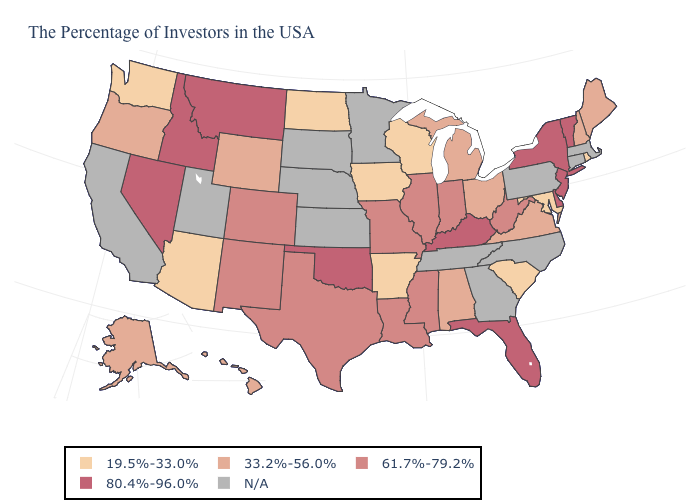Does the map have missing data?
Keep it brief. Yes. What is the value of Florida?
Short answer required. 80.4%-96.0%. What is the value of Florida?
Short answer required. 80.4%-96.0%. Does the map have missing data?
Give a very brief answer. Yes. Does Hawaii have the lowest value in the USA?
Quick response, please. No. How many symbols are there in the legend?
Short answer required. 5. What is the lowest value in states that border North Dakota?
Short answer required. 80.4%-96.0%. What is the highest value in states that border Idaho?
Keep it brief. 80.4%-96.0%. Does the map have missing data?
Answer briefly. Yes. What is the highest value in the West ?
Keep it brief. 80.4%-96.0%. Is the legend a continuous bar?
Answer briefly. No. How many symbols are there in the legend?
Keep it brief. 5. What is the lowest value in the Northeast?
Give a very brief answer. 19.5%-33.0%. 